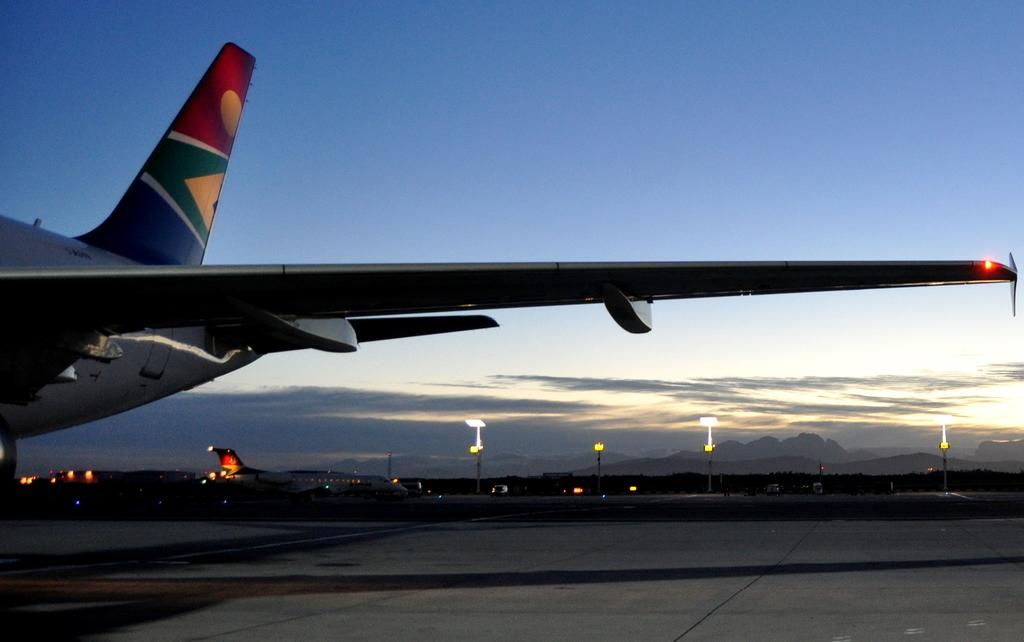What is the main subject in the foreground of the image? There is a truncated airplane on the ground in the foreground. What is happening in the background of the image? There is an airplane moving on the runway in the background. What can be seen in the background besides the moving airplane? There are poles visible in the background. What is visible in the sky in the background? The sky is visible in the background, and clouds are present in the sky. What type of cabbage is growing near the runway in the image? There is no cabbage present in the image; the focus is on the airplanes and the sky. What type of structure is visible near the poles in the background? There is no specific structure mentioned in the provided facts; only poles are mentioned. 